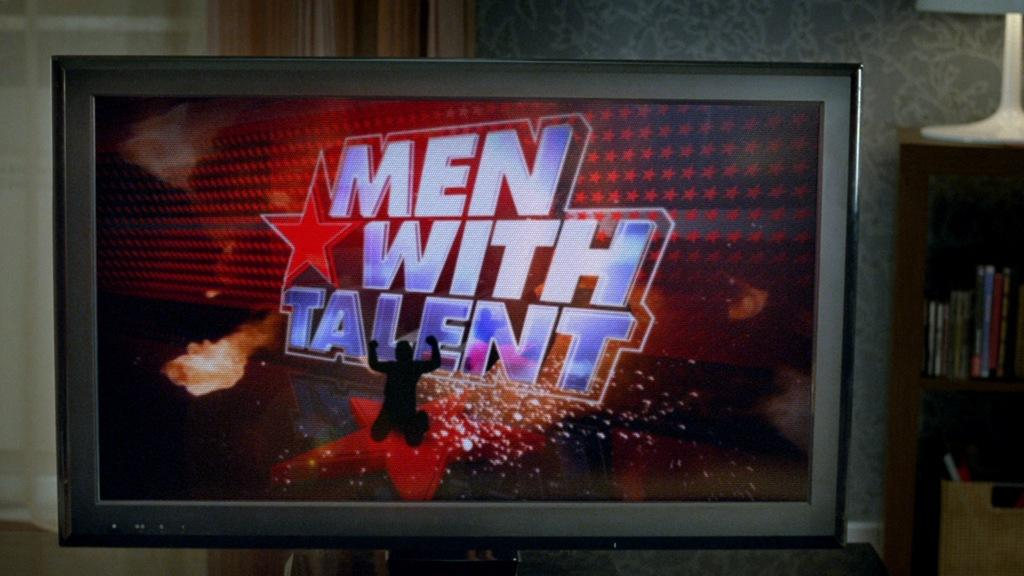<image>
Render a clear and concise summary of the photo. A flat screen TV is showing a program that says Men With Talent. 